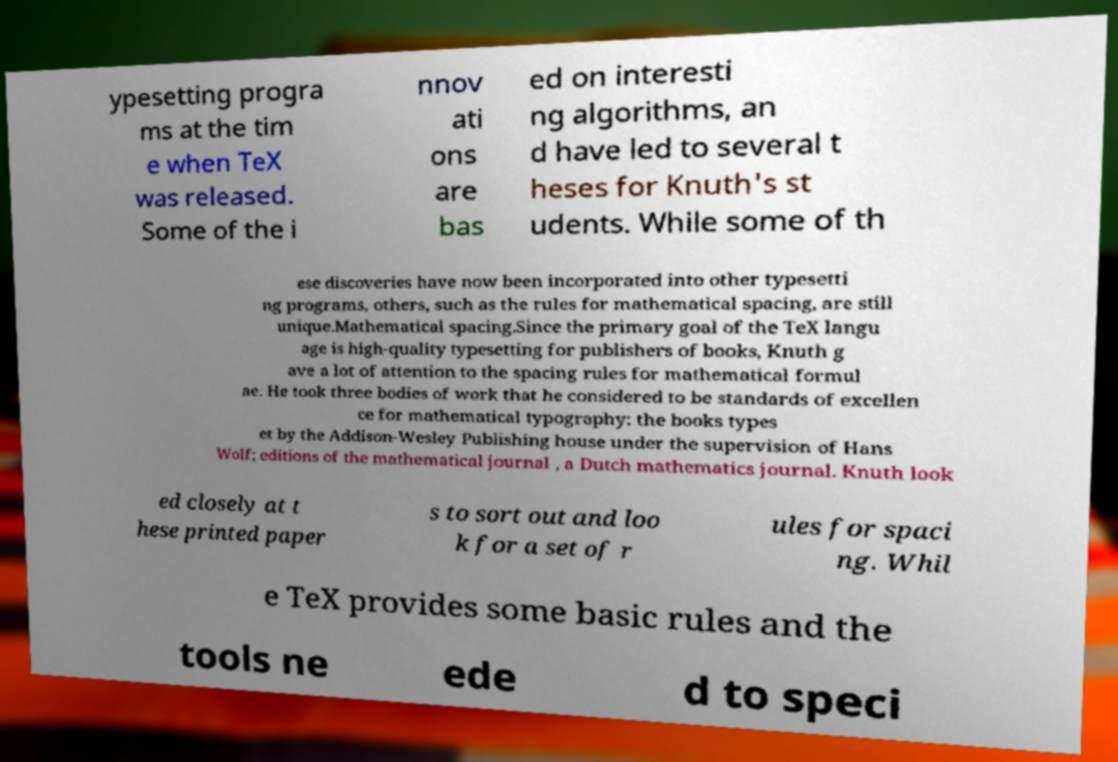I need the written content from this picture converted into text. Can you do that? ypesetting progra ms at the tim e when TeX was released. Some of the i nnov ati ons are bas ed on interesti ng algorithms, an d have led to several t heses for Knuth's st udents. While some of th ese discoveries have now been incorporated into other typesetti ng programs, others, such as the rules for mathematical spacing, are still unique.Mathematical spacing.Since the primary goal of the TeX langu age is high-quality typesetting for publishers of books, Knuth g ave a lot of attention to the spacing rules for mathematical formul ae. He took three bodies of work that he considered to be standards of excellen ce for mathematical typography: the books types et by the Addison-Wesley Publishing house under the supervision of Hans Wolf; editions of the mathematical journal , a Dutch mathematics journal. Knuth look ed closely at t hese printed paper s to sort out and loo k for a set of r ules for spaci ng. Whil e TeX provides some basic rules and the tools ne ede d to speci 